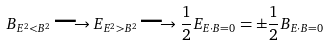Convert formula to latex. <formula><loc_0><loc_0><loc_500><loc_500>B _ { E ^ { 2 } < B ^ { 2 } } \longrightarrow E _ { E ^ { 2 } > B ^ { 2 } } \longrightarrow \frac { 1 } { 2 } E _ { E \cdot B = 0 } = \pm \frac { 1 } { 2 } B _ { E \cdot B = 0 }</formula> 